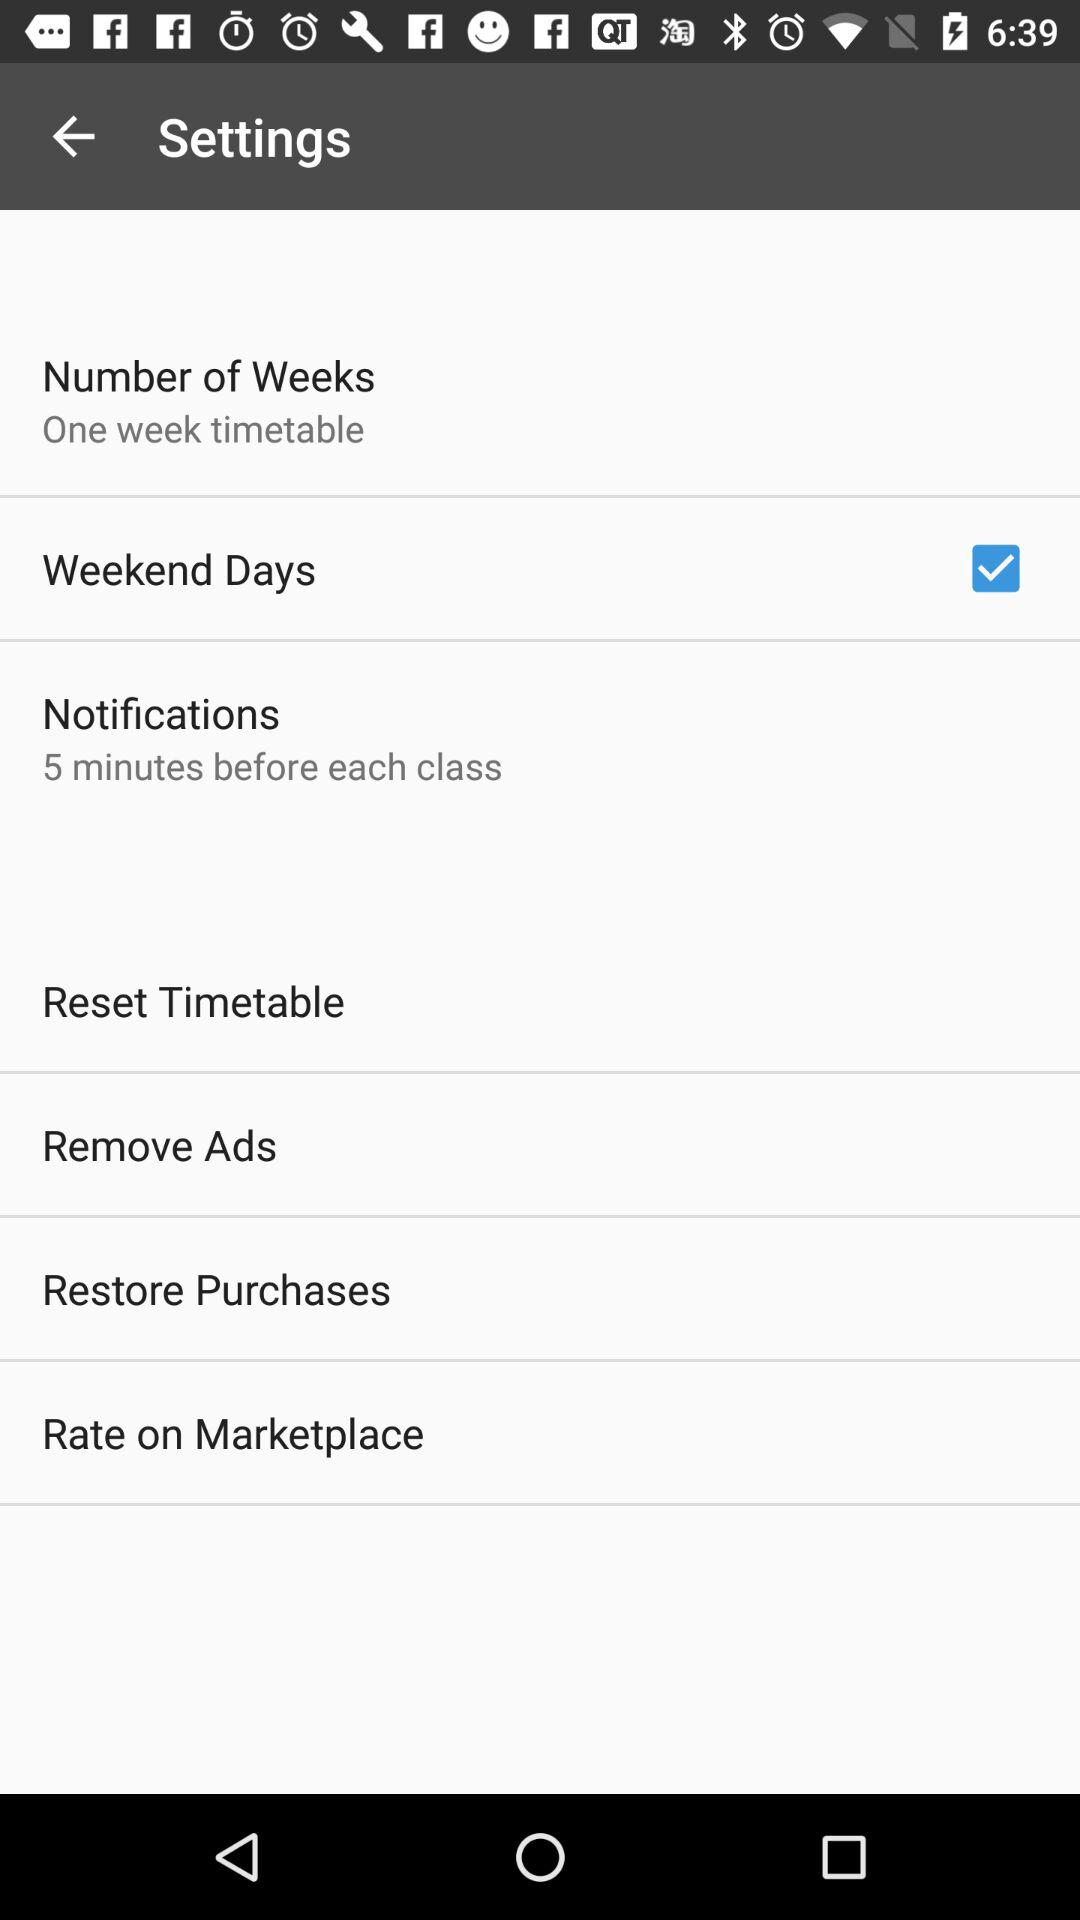When will I receive the notifications? You will receive notifications 5 minutes before each class. 